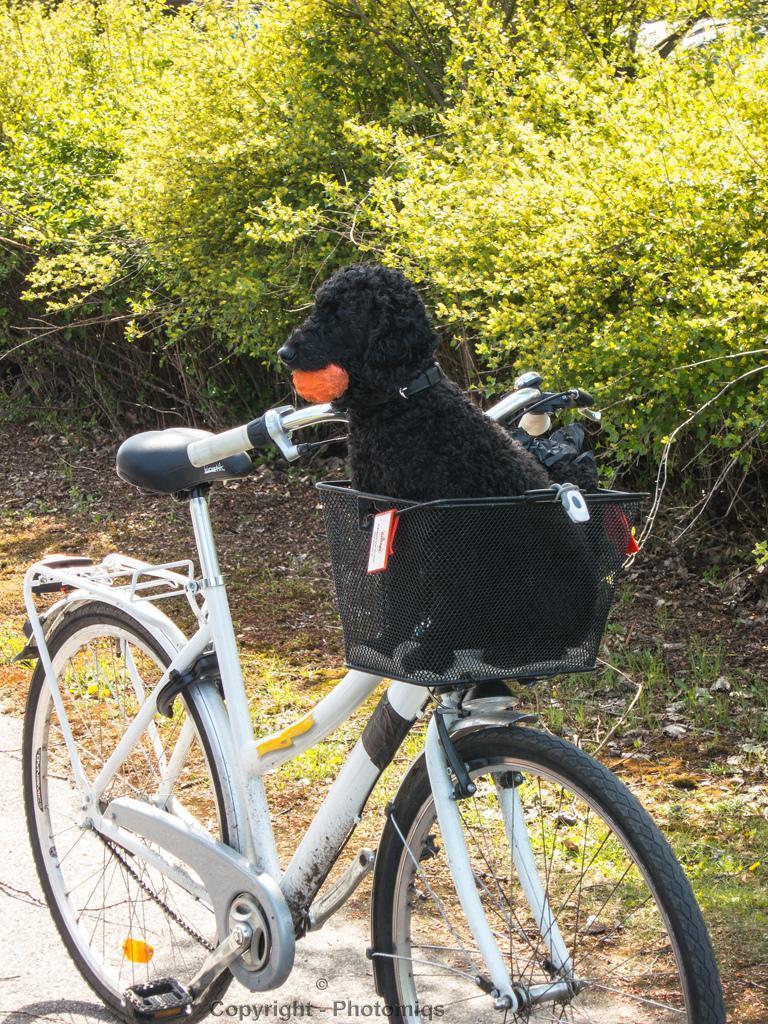How many wheels are on the bike?
Give a very brief answer. 2. How many baskets on the bike?
Give a very brief answer. 1. How many dogs in the picture?
Give a very brief answer. 1. 